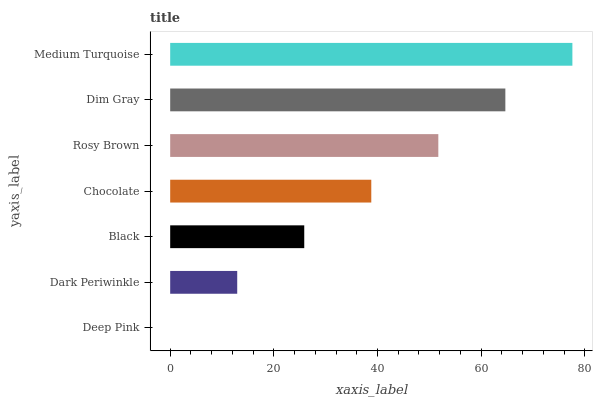Is Deep Pink the minimum?
Answer yes or no. Yes. Is Medium Turquoise the maximum?
Answer yes or no. Yes. Is Dark Periwinkle the minimum?
Answer yes or no. No. Is Dark Periwinkle the maximum?
Answer yes or no. No. Is Dark Periwinkle greater than Deep Pink?
Answer yes or no. Yes. Is Deep Pink less than Dark Periwinkle?
Answer yes or no. Yes. Is Deep Pink greater than Dark Periwinkle?
Answer yes or no. No. Is Dark Periwinkle less than Deep Pink?
Answer yes or no. No. Is Chocolate the high median?
Answer yes or no. Yes. Is Chocolate the low median?
Answer yes or no. Yes. Is Deep Pink the high median?
Answer yes or no. No. Is Dark Periwinkle the low median?
Answer yes or no. No. 